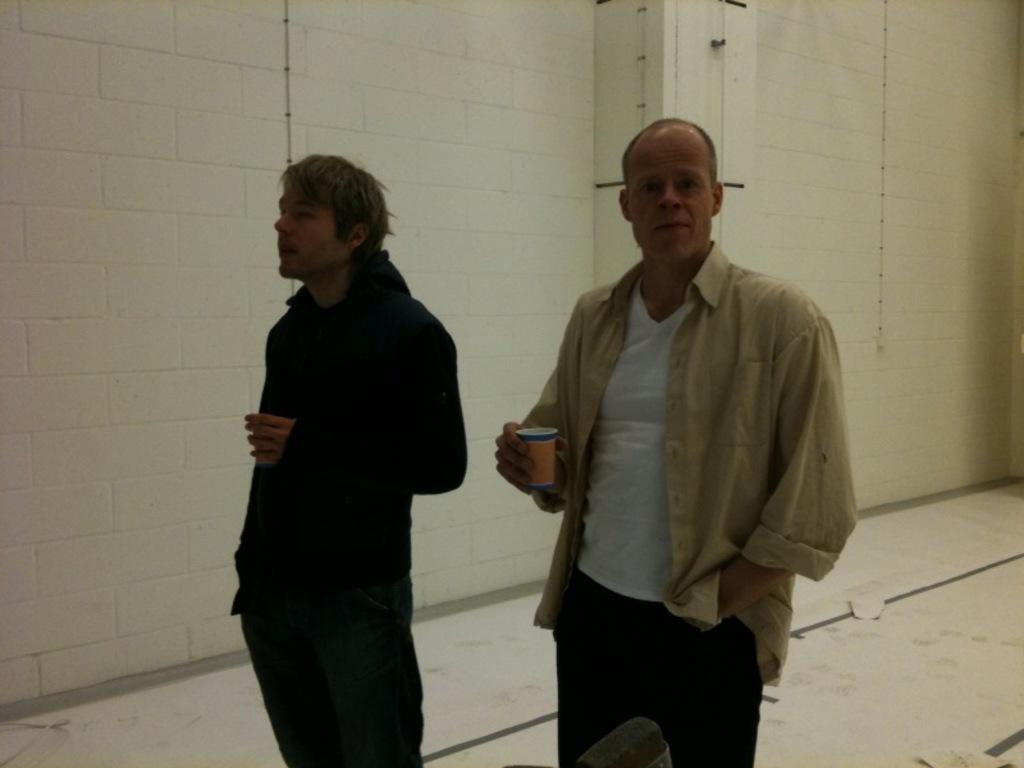In one or two sentences, can you explain what this image depicts? In this image, we can see people and are holding cups. In the background, there is a wall. At the bottom, there is a floor. 